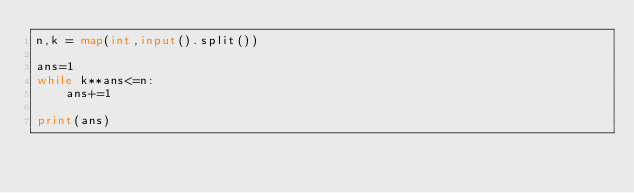<code> <loc_0><loc_0><loc_500><loc_500><_Python_>n,k = map(int,input().split())

ans=1
while k**ans<=n:
    ans+=1

print(ans)</code> 